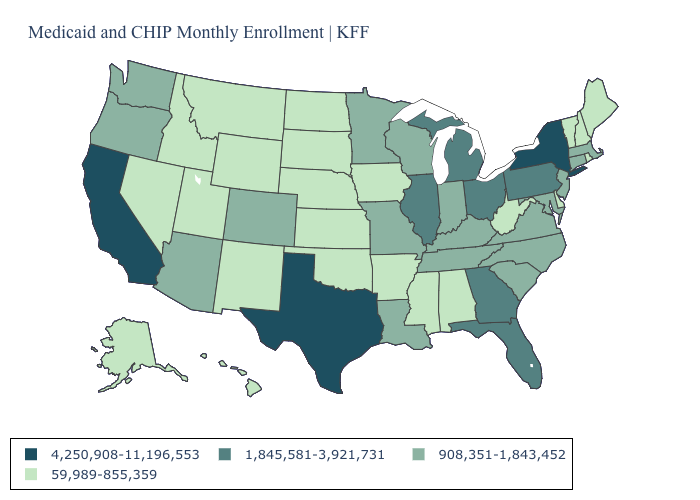What is the value of Minnesota?
Concise answer only. 908,351-1,843,452. What is the value of New York?
Keep it brief. 4,250,908-11,196,553. Among the states that border Delaware , does New Jersey have the lowest value?
Write a very short answer. Yes. What is the value of New York?
Answer briefly. 4,250,908-11,196,553. Name the states that have a value in the range 1,845,581-3,921,731?
Concise answer only. Florida, Georgia, Illinois, Michigan, Ohio, Pennsylvania. Name the states that have a value in the range 1,845,581-3,921,731?
Short answer required. Florida, Georgia, Illinois, Michigan, Ohio, Pennsylvania. Does North Carolina have the lowest value in the USA?
Be succinct. No. What is the value of Washington?
Short answer required. 908,351-1,843,452. Among the states that border Mississippi , does Alabama have the highest value?
Short answer required. No. Is the legend a continuous bar?
Write a very short answer. No. Does the map have missing data?
Keep it brief. No. What is the lowest value in the West?
Give a very brief answer. 59,989-855,359. Name the states that have a value in the range 4,250,908-11,196,553?
Concise answer only. California, New York, Texas. Name the states that have a value in the range 1,845,581-3,921,731?
Keep it brief. Florida, Georgia, Illinois, Michigan, Ohio, Pennsylvania. Among the states that border Massachusetts , does Vermont have the highest value?
Concise answer only. No. 